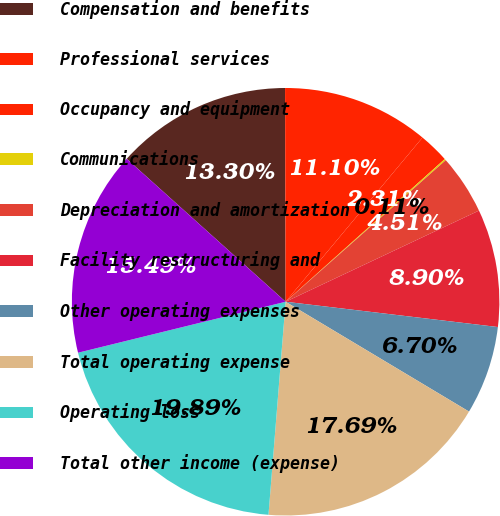<chart> <loc_0><loc_0><loc_500><loc_500><pie_chart><fcel>Compensation and benefits<fcel>Professional services<fcel>Occupancy and equipment<fcel>Communications<fcel>Depreciation and amortization<fcel>Facility restructuring and<fcel>Other operating expenses<fcel>Total operating expense<fcel>Operating loss<fcel>Total other income (expense)<nl><fcel>13.3%<fcel>11.1%<fcel>2.31%<fcel>0.11%<fcel>4.51%<fcel>8.9%<fcel>6.7%<fcel>17.69%<fcel>19.89%<fcel>15.49%<nl></chart> 